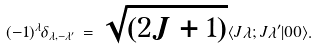<formula> <loc_0><loc_0><loc_500><loc_500>( - 1 ) ^ { \lambda } \delta _ { \lambda , - \lambda ^ { \prime } } \, = \, \sqrt { ( 2 J + 1 ) } \langle J \lambda ; J \lambda ^ { \prime } | 0 0 \rangle .</formula> 